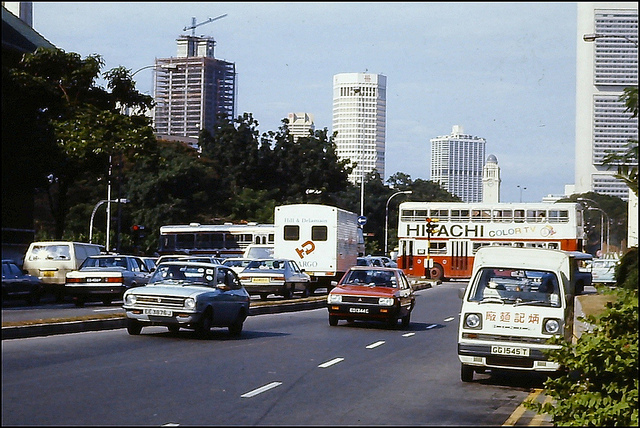Is there any indication of the time of day or year this photo was taken? The shadows are relatively short, implying the photo was taken midday. The clarity of the sky and the greenery suggests it may be during a warmer season, possibly spring or summer. 